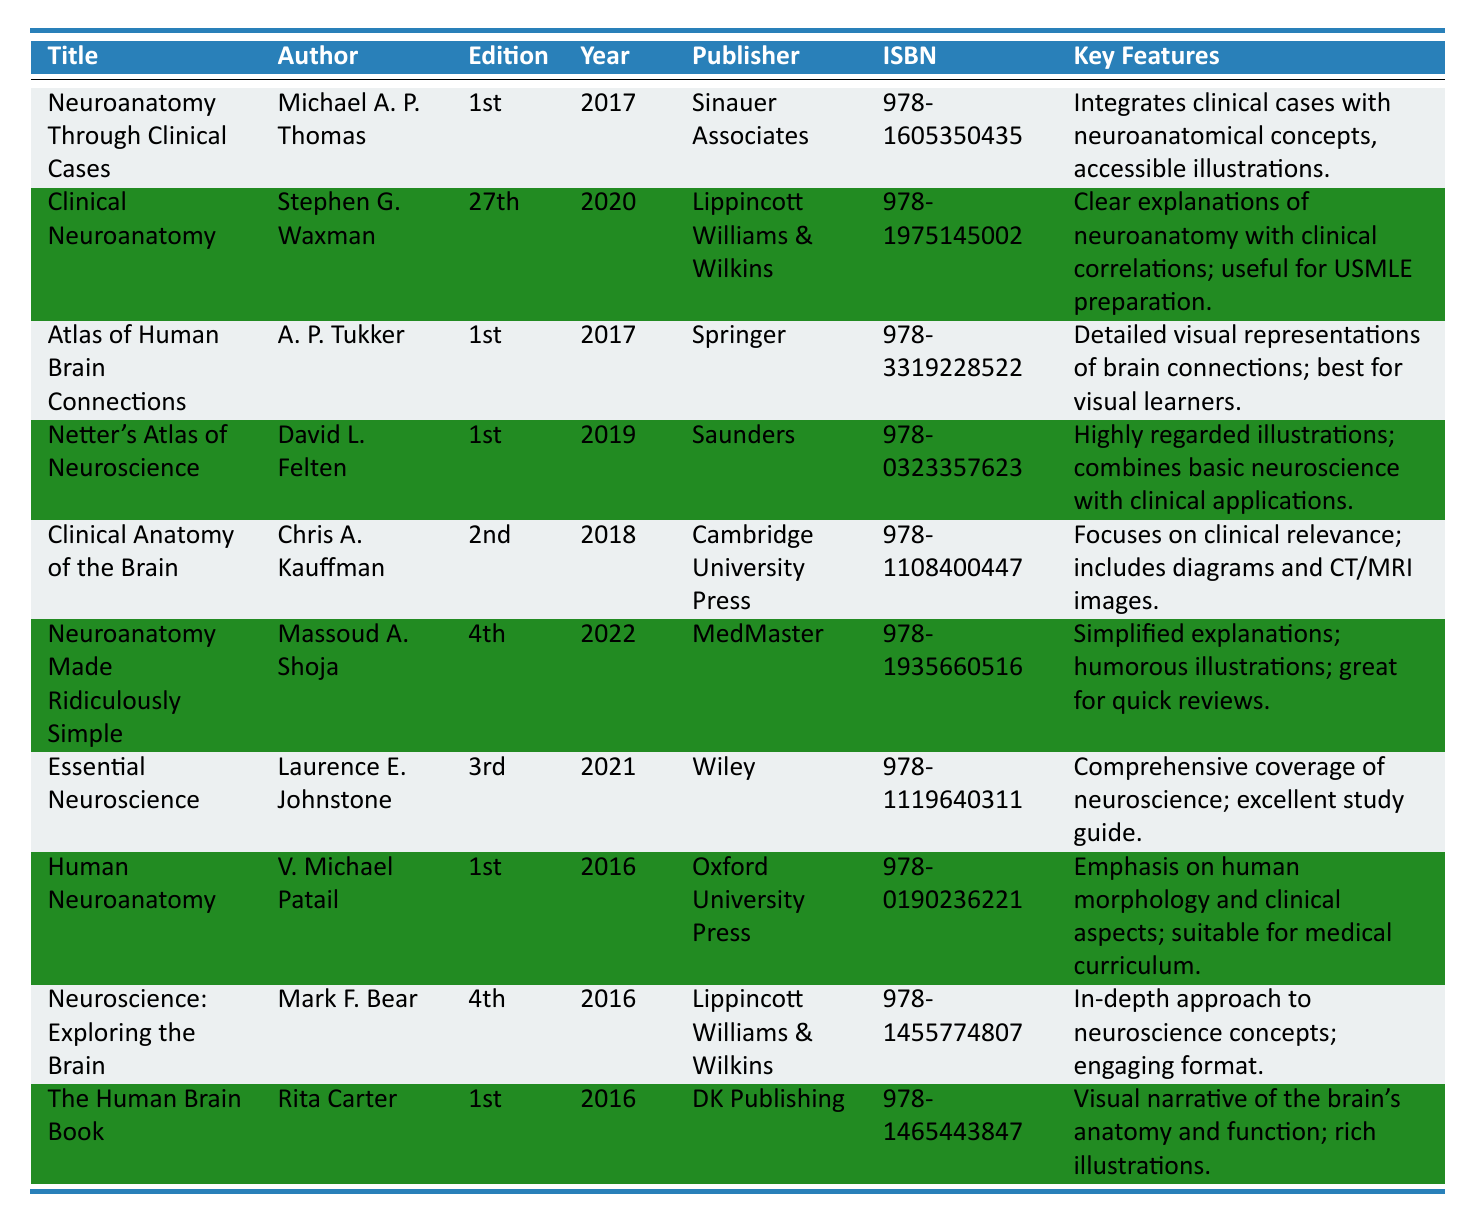What is the title of the book authored by Stephen G. Waxman? The book authored by Stephen G. Waxman is listed under the Title column in the table. According to the table data, the title is "Clinical Neuroanatomy."
Answer: Clinical Neuroanatomy How many editions has "Neuroanatomy Made Ridiculously Simple" gone through? The table shows that "Neuroanatomy Made Ridiculously Simple" is currently on its 4th edition, as indicated in the corresponding column for editions.
Answer: 4th Which book was published in the year 2018? By reviewing the publication year column in the table, I can see that "Clinical Anatomy of the Brain" and "Neuroanatomy Made Ridiculously Simple" were both published in 2018.
Answer: Clinical Anatomy of the Brain, Neuroanatomy Made Ridiculously Simple Is "Essential Neuroscience" by Laurence E. Johnstone the latest edition? Referring to the year of publication of "Essential Neuroscience," which is 2021, it confirms it is not the latest edition since there are other books published after that year, such as "Neuroanatomy Made Ridiculously Simple" (2022).
Answer: No How many books were published after 2017? A review of the publication year data shows that the books published after 2017 are "Clinical Neuroanatomy" (2020), "Neuroanatomy Made Ridiculously Simple" (2022), and "Essential Neuroscience" (2021). Counting, there are four books published after 2017.
Answer: 4 What are the key features of the book "Netter's Atlas of Neuroscience"? The table explicitly lists the key features of "Netter's Atlas of Neuroscience," which includes "Highly regarded illustrations; combines basic neuroscience with clinical applications."
Answer: Highly regarded illustrations; combines basic neuroscience with clinical applications Which book focuses on visual representations of brain connections? The table indicates that the book "Atlas of Human Brain Connections" focuses on this aspect as mentioned in its key features: "Detailed visual representations of brain connections; best for visual learners."
Answer: Atlas of Human Brain Connections Which author wrote more than one book in the table? By examining the authors listed, I find there are no duplicate names; therefore, verifying each author corresponds to one unique book listed in the table confirms this.
Answer: No Determine the average publication year of the books listed in the table. First, I will sum the publication years: (2017 + 2020 + 2017 + 2019 + 2018 + 2022 + 2021 + 2016 + 2016 + 2016) = 2018. Then, I divide by the total number of books, which is 10, resulting in 2018/10 = 2018.
Answer: 2018 What is the publisher of "Neuroscience: Exploring the Brain"? The table specifies the publisher for "Neuroscience: Exploring the Brain" under the Publisher column, which shows that it is published by "Lippincott Williams & Wilkins."
Answer: Lippincott Williams & Wilkins Which book has the key feature of "humorous illustrations"? Referring to the Key Features column in the table, it specifies that "Neuroanatomy Made Ridiculously Simple" has "humorous illustrations."
Answer: Neuroanatomy Made Ridiculously Simple 